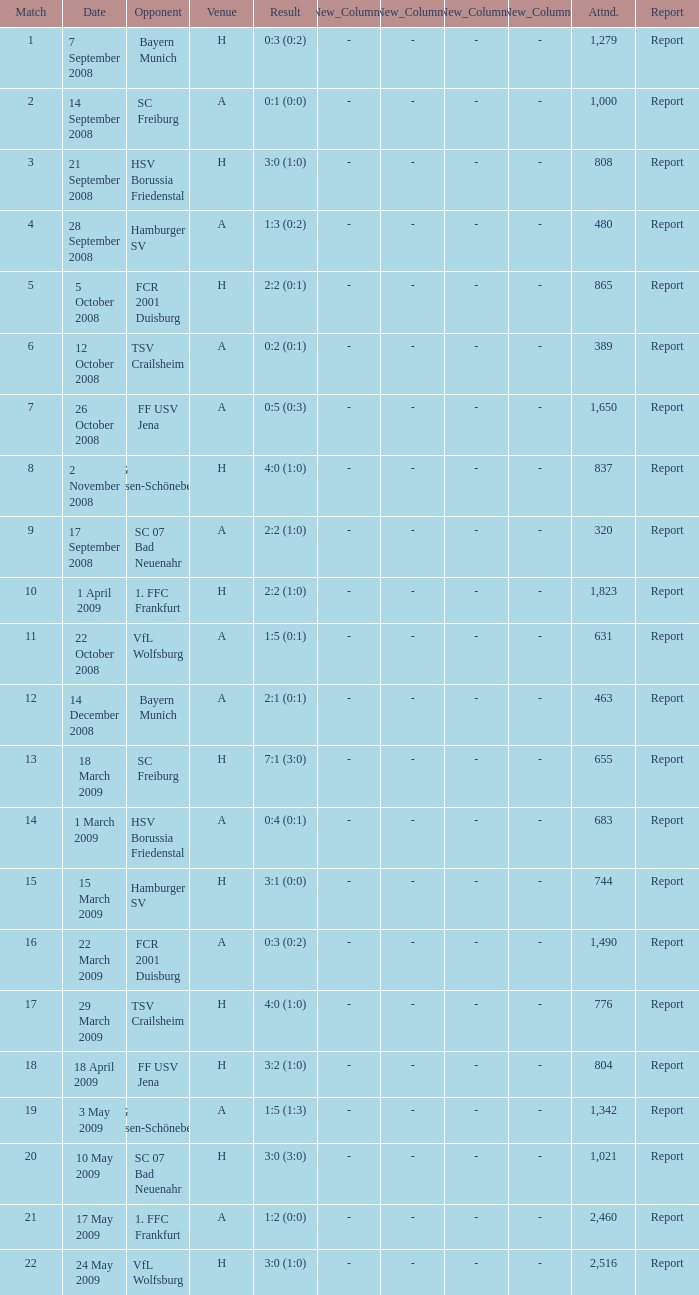Which match did FCR 2001 Duisburg participate as the opponent? 21.0. 